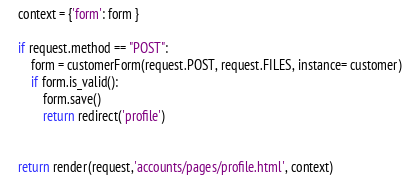Convert code to text. <code><loc_0><loc_0><loc_500><loc_500><_Python_>    context = {'form': form }

    if request.method == "POST":
        form = customerForm(request.POST, request.FILES, instance= customer)
        if form.is_valid():
            form.save()
            return redirect('profile')
            

    return render(request,'accounts/pages/profile.html', context)</code> 